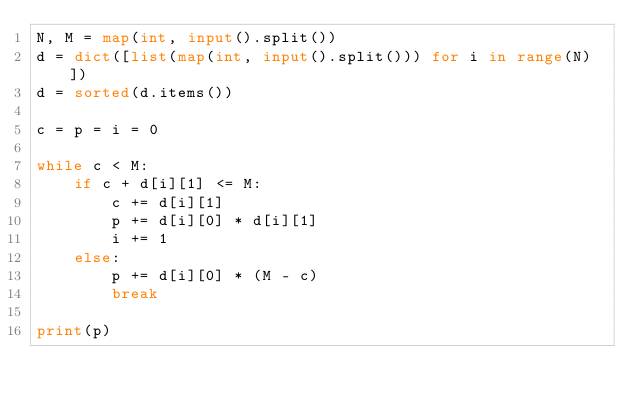<code> <loc_0><loc_0><loc_500><loc_500><_Python_>N, M = map(int, input().split())
d = dict([list(map(int, input().split())) for i in range(N)])
d = sorted(d.items())

c = p = i = 0

while c < M:
    if c + d[i][1] <= M:
        c += d[i][1]
        p += d[i][0] * d[i][1]
        i += 1
    else:
        p += d[i][0] * (M - c)
        break

print(p)
</code> 